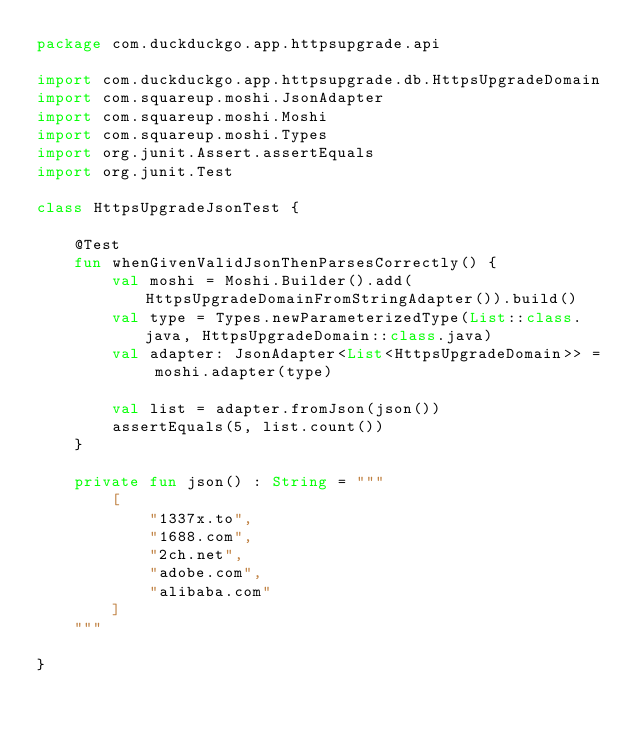Convert code to text. <code><loc_0><loc_0><loc_500><loc_500><_Kotlin_>package com.duckduckgo.app.httpsupgrade.api

import com.duckduckgo.app.httpsupgrade.db.HttpsUpgradeDomain
import com.squareup.moshi.JsonAdapter
import com.squareup.moshi.Moshi
import com.squareup.moshi.Types
import org.junit.Assert.assertEquals
import org.junit.Test

class HttpsUpgradeJsonTest {

    @Test
    fun whenGivenValidJsonThenParsesCorrectly() {
        val moshi = Moshi.Builder().add(HttpsUpgradeDomainFromStringAdapter()).build()
        val type = Types.newParameterizedType(List::class.java, HttpsUpgradeDomain::class.java)
        val adapter: JsonAdapter<List<HttpsUpgradeDomain>> = moshi.adapter(type)

        val list = adapter.fromJson(json())
        assertEquals(5, list.count())
    }

    private fun json() : String = """
        [
            "1337x.to",
            "1688.com",
            "2ch.net",
            "adobe.com",
            "alibaba.com"
        ]
    """

}</code> 